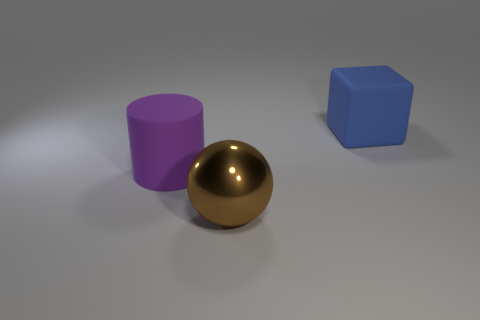What shape is the large object that is left of the big brown shiny object?
Make the answer very short. Cylinder. Are there any blocks behind the shiny object?
Provide a succinct answer. Yes. Is there any other thing that is the same size as the blue thing?
Provide a succinct answer. Yes. The cylinder that is the same material as the blue block is what color?
Provide a succinct answer. Purple. Does the rubber object that is in front of the blue rubber object have the same color as the object that is in front of the purple matte cylinder?
Your answer should be very brief. No. What number of balls are either large brown objects or big blue rubber objects?
Provide a short and direct response. 1. Are there the same number of large rubber things behind the purple rubber cylinder and spheres?
Give a very brief answer. Yes. There is a big object that is in front of the large thing to the left of the thing in front of the large purple matte object; what is its material?
Offer a very short reply. Metal. What number of objects are objects that are in front of the large blue rubber cube or large brown shiny balls?
Offer a very short reply. 2. What number of things are purple rubber cylinders or objects to the left of the large blue matte object?
Ensure brevity in your answer.  2. 